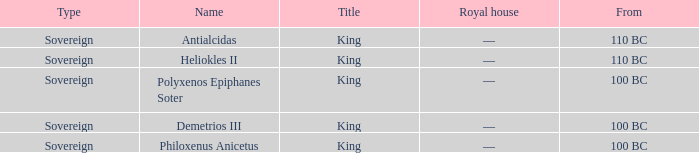To which royal lineage does polyxenos epiphanes soter belong? —. 